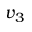<formula> <loc_0><loc_0><loc_500><loc_500>v _ { 3 }</formula> 